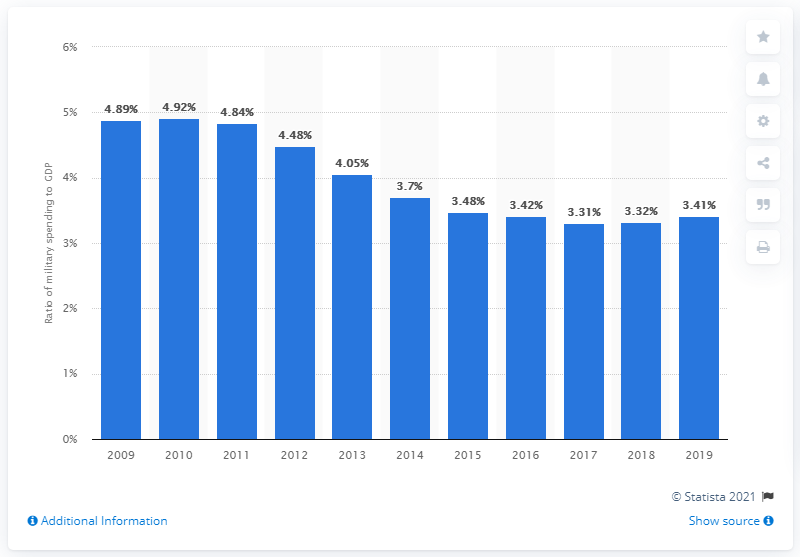List a handful of essential elements in this visual. In 2019, military expenditure in the United States accounted for 3.41% of the country's gross domestic product. 